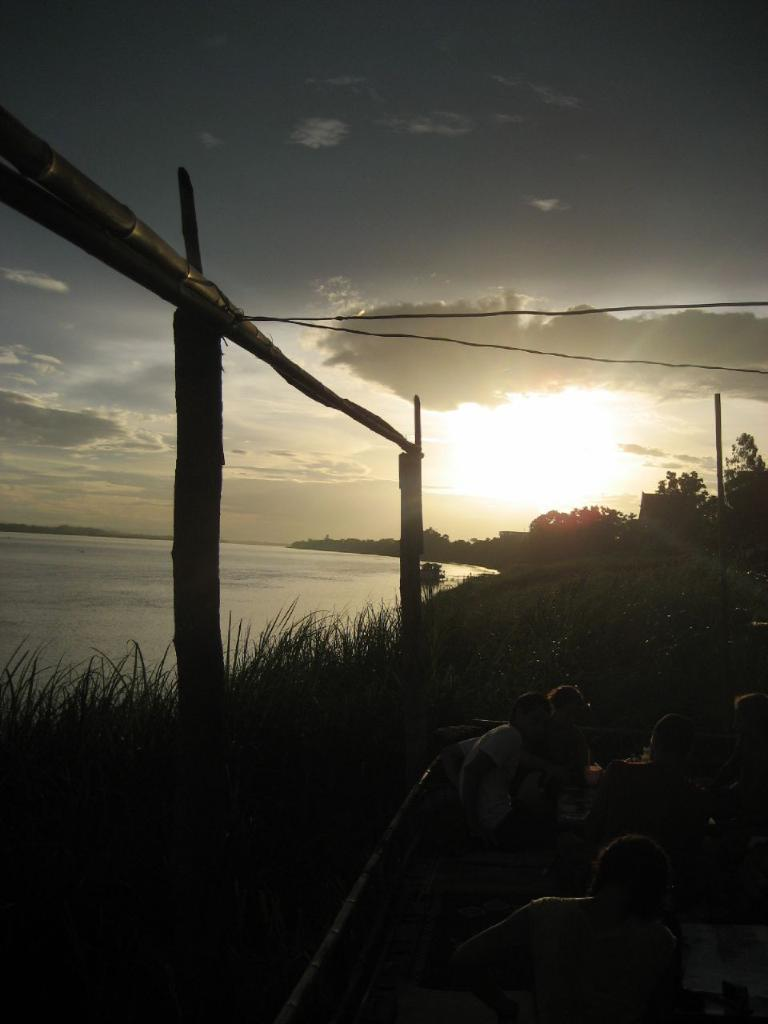What are the people in the image doing? The people in the image are sitting on an object. Can you describe the object they are sitting on? The object is on the surface of the grass. What type of structure can be seen in the image? There is a wooden structure in the image. What can be seen in the background of the image? There are trees and the sky visible in the background of the image. What type of toothbrush is being used to clean the wooden structure in the image? There is no toothbrush present in the image, and the wooden structure is not being cleaned. 